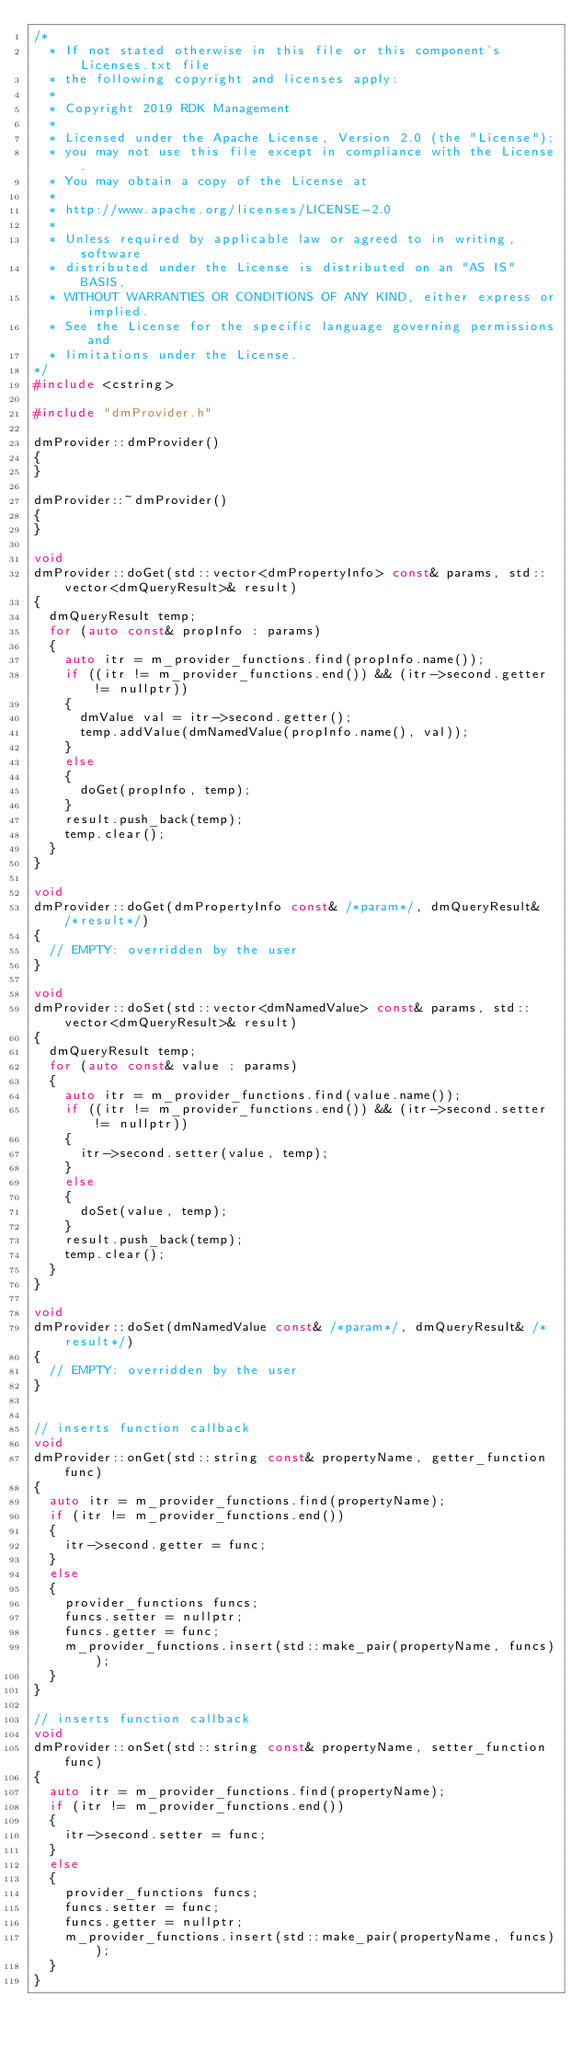<code> <loc_0><loc_0><loc_500><loc_500><_C++_>/*
  * If not stated otherwise in this file or this component's Licenses.txt file
  * the following copyright and licenses apply:
  *
  * Copyright 2019 RDK Management
  *
  * Licensed under the Apache License, Version 2.0 (the "License");
  * you may not use this file except in compliance with the License.
  * You may obtain a copy of the License at
  *
  * http://www.apache.org/licenses/LICENSE-2.0
  *
  * Unless required by applicable law or agreed to in writing, software
  * distributed under the License is distributed on an "AS IS" BASIS,
  * WITHOUT WARRANTIES OR CONDITIONS OF ANY KIND, either express or implied.
  * See the License for the specific language governing permissions and
  * limitations under the License.
*/
#include <cstring>

#include "dmProvider.h"

dmProvider::dmProvider()
{
}

dmProvider::~dmProvider()
{
}

void
dmProvider::doGet(std::vector<dmPropertyInfo> const& params, std::vector<dmQueryResult>& result)
{
  dmQueryResult temp;
  for (auto const& propInfo : params)
  {
    auto itr = m_provider_functions.find(propInfo.name());
    if ((itr != m_provider_functions.end()) && (itr->second.getter != nullptr))
    {
      dmValue val = itr->second.getter();
      temp.addValue(dmNamedValue(propInfo.name(), val));
    }
    else
    {
      doGet(propInfo, temp);
    }
    result.push_back(temp);
    temp.clear();
  }
}

void
dmProvider::doGet(dmPropertyInfo const& /*param*/, dmQueryResult& /*result*/)
{
  // EMPTY: overridden by the user 
}

void
dmProvider::doSet(std::vector<dmNamedValue> const& params, std::vector<dmQueryResult>& result)
{
  dmQueryResult temp;
  for (auto const& value : params)
  {
    auto itr = m_provider_functions.find(value.name());
    if ((itr != m_provider_functions.end()) && (itr->second.setter != nullptr))
    {
      itr->second.setter(value, temp);
    }
    else
    {
      doSet(value, temp);
    }
    result.push_back(temp);
    temp.clear();
  }
}

void
dmProvider::doSet(dmNamedValue const& /*param*/, dmQueryResult& /*result*/)
{
  // EMPTY: overridden by the user 
}


// inserts function callback
void
dmProvider::onGet(std::string const& propertyName, getter_function func)
{
  auto itr = m_provider_functions.find(propertyName);
  if (itr != m_provider_functions.end())
  {
    itr->second.getter = func;
  }
  else
  {
    provider_functions funcs;
    funcs.setter = nullptr;
    funcs.getter = func;
    m_provider_functions.insert(std::make_pair(propertyName, funcs));
  }
}

// inserts function callback
void
dmProvider::onSet(std::string const& propertyName, setter_function func)
{
  auto itr = m_provider_functions.find(propertyName);
  if (itr != m_provider_functions.end())
  {
    itr->second.setter = func;
  }
  else
  {
    provider_functions funcs;
    funcs.setter = func;
    funcs.getter = nullptr;
    m_provider_functions.insert(std::make_pair(propertyName, funcs));
  }
}
</code> 